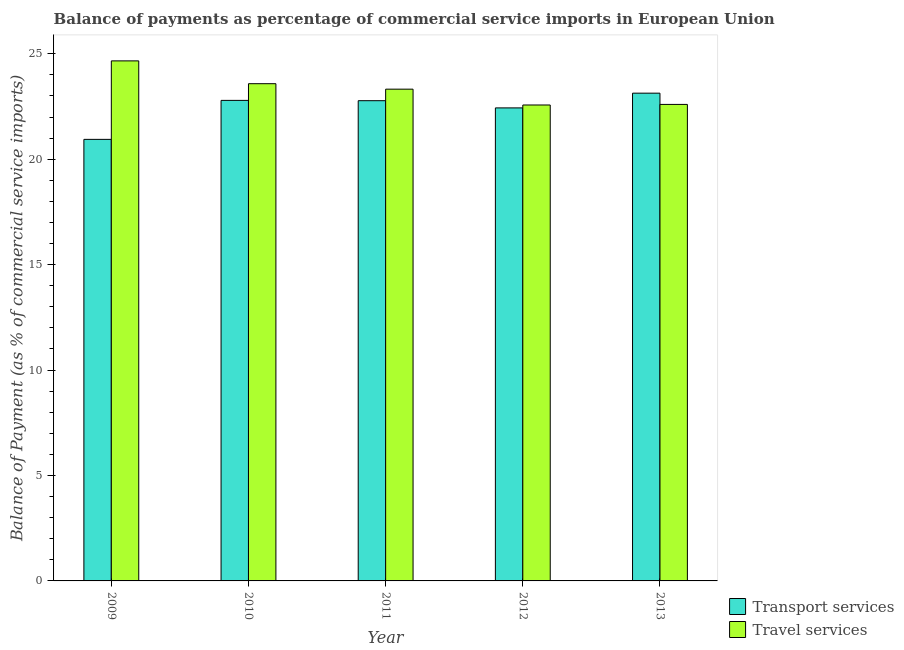How many different coloured bars are there?
Your answer should be compact. 2. How many groups of bars are there?
Give a very brief answer. 5. Are the number of bars per tick equal to the number of legend labels?
Keep it short and to the point. Yes. Are the number of bars on each tick of the X-axis equal?
Give a very brief answer. Yes. In how many cases, is the number of bars for a given year not equal to the number of legend labels?
Give a very brief answer. 0. What is the balance of payments of travel services in 2013?
Ensure brevity in your answer.  22.6. Across all years, what is the maximum balance of payments of transport services?
Your response must be concise. 23.13. Across all years, what is the minimum balance of payments of transport services?
Your response must be concise. 20.94. What is the total balance of payments of travel services in the graph?
Your answer should be very brief. 116.74. What is the difference between the balance of payments of transport services in 2009 and that in 2011?
Keep it short and to the point. -1.83. What is the difference between the balance of payments of transport services in 2011 and the balance of payments of travel services in 2009?
Offer a very short reply. 1.83. What is the average balance of payments of travel services per year?
Give a very brief answer. 23.35. In how many years, is the balance of payments of transport services greater than 15 %?
Offer a terse response. 5. What is the ratio of the balance of payments of transport services in 2009 to that in 2013?
Give a very brief answer. 0.91. What is the difference between the highest and the second highest balance of payments of transport services?
Provide a short and direct response. 0.34. What is the difference between the highest and the lowest balance of payments of travel services?
Ensure brevity in your answer.  2.09. Is the sum of the balance of payments of transport services in 2009 and 2011 greater than the maximum balance of payments of travel services across all years?
Provide a succinct answer. Yes. What does the 2nd bar from the left in 2013 represents?
Provide a succinct answer. Travel services. What does the 2nd bar from the right in 2011 represents?
Offer a very short reply. Transport services. How many bars are there?
Your answer should be very brief. 10. Are all the bars in the graph horizontal?
Provide a short and direct response. No. What is the difference between two consecutive major ticks on the Y-axis?
Your response must be concise. 5. Does the graph contain grids?
Give a very brief answer. No. What is the title of the graph?
Offer a very short reply. Balance of payments as percentage of commercial service imports in European Union. Does "Female labourers" appear as one of the legend labels in the graph?
Make the answer very short. No. What is the label or title of the X-axis?
Make the answer very short. Year. What is the label or title of the Y-axis?
Provide a short and direct response. Balance of Payment (as % of commercial service imports). What is the Balance of Payment (as % of commercial service imports) of Transport services in 2009?
Provide a short and direct response. 20.94. What is the Balance of Payment (as % of commercial service imports) in Travel services in 2009?
Keep it short and to the point. 24.66. What is the Balance of Payment (as % of commercial service imports) of Transport services in 2010?
Keep it short and to the point. 22.79. What is the Balance of Payment (as % of commercial service imports) in Travel services in 2010?
Provide a succinct answer. 23.58. What is the Balance of Payment (as % of commercial service imports) in Transport services in 2011?
Offer a terse response. 22.78. What is the Balance of Payment (as % of commercial service imports) in Travel services in 2011?
Provide a short and direct response. 23.32. What is the Balance of Payment (as % of commercial service imports) in Transport services in 2012?
Your answer should be very brief. 22.43. What is the Balance of Payment (as % of commercial service imports) of Travel services in 2012?
Give a very brief answer. 22.57. What is the Balance of Payment (as % of commercial service imports) in Transport services in 2013?
Give a very brief answer. 23.13. What is the Balance of Payment (as % of commercial service imports) in Travel services in 2013?
Your answer should be very brief. 22.6. Across all years, what is the maximum Balance of Payment (as % of commercial service imports) in Transport services?
Your answer should be compact. 23.13. Across all years, what is the maximum Balance of Payment (as % of commercial service imports) in Travel services?
Your answer should be compact. 24.66. Across all years, what is the minimum Balance of Payment (as % of commercial service imports) in Transport services?
Make the answer very short. 20.94. Across all years, what is the minimum Balance of Payment (as % of commercial service imports) in Travel services?
Give a very brief answer. 22.57. What is the total Balance of Payment (as % of commercial service imports) in Transport services in the graph?
Your response must be concise. 112.07. What is the total Balance of Payment (as % of commercial service imports) of Travel services in the graph?
Your answer should be very brief. 116.74. What is the difference between the Balance of Payment (as % of commercial service imports) of Transport services in 2009 and that in 2010?
Your answer should be compact. -1.85. What is the difference between the Balance of Payment (as % of commercial service imports) in Travel services in 2009 and that in 2010?
Provide a short and direct response. 1.08. What is the difference between the Balance of Payment (as % of commercial service imports) in Transport services in 2009 and that in 2011?
Give a very brief answer. -1.83. What is the difference between the Balance of Payment (as % of commercial service imports) in Travel services in 2009 and that in 2011?
Provide a short and direct response. 1.34. What is the difference between the Balance of Payment (as % of commercial service imports) of Transport services in 2009 and that in 2012?
Offer a terse response. -1.49. What is the difference between the Balance of Payment (as % of commercial service imports) in Travel services in 2009 and that in 2012?
Your answer should be very brief. 2.09. What is the difference between the Balance of Payment (as % of commercial service imports) in Transport services in 2009 and that in 2013?
Make the answer very short. -2.19. What is the difference between the Balance of Payment (as % of commercial service imports) in Travel services in 2009 and that in 2013?
Offer a terse response. 2.07. What is the difference between the Balance of Payment (as % of commercial service imports) in Transport services in 2010 and that in 2011?
Provide a short and direct response. 0.01. What is the difference between the Balance of Payment (as % of commercial service imports) in Travel services in 2010 and that in 2011?
Make the answer very short. 0.26. What is the difference between the Balance of Payment (as % of commercial service imports) of Transport services in 2010 and that in 2012?
Give a very brief answer. 0.36. What is the difference between the Balance of Payment (as % of commercial service imports) of Travel services in 2010 and that in 2012?
Provide a short and direct response. 1.01. What is the difference between the Balance of Payment (as % of commercial service imports) of Transport services in 2010 and that in 2013?
Provide a short and direct response. -0.34. What is the difference between the Balance of Payment (as % of commercial service imports) of Travel services in 2010 and that in 2013?
Give a very brief answer. 0.98. What is the difference between the Balance of Payment (as % of commercial service imports) of Transport services in 2011 and that in 2012?
Your response must be concise. 0.34. What is the difference between the Balance of Payment (as % of commercial service imports) of Travel services in 2011 and that in 2012?
Your answer should be compact. 0.75. What is the difference between the Balance of Payment (as % of commercial service imports) of Transport services in 2011 and that in 2013?
Your answer should be compact. -0.36. What is the difference between the Balance of Payment (as % of commercial service imports) of Travel services in 2011 and that in 2013?
Keep it short and to the point. 0.72. What is the difference between the Balance of Payment (as % of commercial service imports) of Transport services in 2012 and that in 2013?
Your response must be concise. -0.7. What is the difference between the Balance of Payment (as % of commercial service imports) in Travel services in 2012 and that in 2013?
Offer a very short reply. -0.03. What is the difference between the Balance of Payment (as % of commercial service imports) of Transport services in 2009 and the Balance of Payment (as % of commercial service imports) of Travel services in 2010?
Your response must be concise. -2.64. What is the difference between the Balance of Payment (as % of commercial service imports) in Transport services in 2009 and the Balance of Payment (as % of commercial service imports) in Travel services in 2011?
Your answer should be very brief. -2.38. What is the difference between the Balance of Payment (as % of commercial service imports) in Transport services in 2009 and the Balance of Payment (as % of commercial service imports) in Travel services in 2012?
Make the answer very short. -1.63. What is the difference between the Balance of Payment (as % of commercial service imports) in Transport services in 2009 and the Balance of Payment (as % of commercial service imports) in Travel services in 2013?
Give a very brief answer. -1.66. What is the difference between the Balance of Payment (as % of commercial service imports) in Transport services in 2010 and the Balance of Payment (as % of commercial service imports) in Travel services in 2011?
Your answer should be very brief. -0.53. What is the difference between the Balance of Payment (as % of commercial service imports) in Transport services in 2010 and the Balance of Payment (as % of commercial service imports) in Travel services in 2012?
Provide a succinct answer. 0.22. What is the difference between the Balance of Payment (as % of commercial service imports) of Transport services in 2010 and the Balance of Payment (as % of commercial service imports) of Travel services in 2013?
Offer a very short reply. 0.19. What is the difference between the Balance of Payment (as % of commercial service imports) in Transport services in 2011 and the Balance of Payment (as % of commercial service imports) in Travel services in 2012?
Your answer should be compact. 0.2. What is the difference between the Balance of Payment (as % of commercial service imports) of Transport services in 2011 and the Balance of Payment (as % of commercial service imports) of Travel services in 2013?
Provide a short and direct response. 0.18. What is the difference between the Balance of Payment (as % of commercial service imports) in Transport services in 2012 and the Balance of Payment (as % of commercial service imports) in Travel services in 2013?
Keep it short and to the point. -0.16. What is the average Balance of Payment (as % of commercial service imports) in Transport services per year?
Your answer should be very brief. 22.41. What is the average Balance of Payment (as % of commercial service imports) in Travel services per year?
Your response must be concise. 23.35. In the year 2009, what is the difference between the Balance of Payment (as % of commercial service imports) of Transport services and Balance of Payment (as % of commercial service imports) of Travel services?
Your answer should be compact. -3.72. In the year 2010, what is the difference between the Balance of Payment (as % of commercial service imports) of Transport services and Balance of Payment (as % of commercial service imports) of Travel services?
Your response must be concise. -0.79. In the year 2011, what is the difference between the Balance of Payment (as % of commercial service imports) in Transport services and Balance of Payment (as % of commercial service imports) in Travel services?
Your answer should be compact. -0.55. In the year 2012, what is the difference between the Balance of Payment (as % of commercial service imports) in Transport services and Balance of Payment (as % of commercial service imports) in Travel services?
Your answer should be compact. -0.14. In the year 2013, what is the difference between the Balance of Payment (as % of commercial service imports) in Transport services and Balance of Payment (as % of commercial service imports) in Travel services?
Give a very brief answer. 0.53. What is the ratio of the Balance of Payment (as % of commercial service imports) of Transport services in 2009 to that in 2010?
Provide a short and direct response. 0.92. What is the ratio of the Balance of Payment (as % of commercial service imports) of Travel services in 2009 to that in 2010?
Your response must be concise. 1.05. What is the ratio of the Balance of Payment (as % of commercial service imports) in Transport services in 2009 to that in 2011?
Give a very brief answer. 0.92. What is the ratio of the Balance of Payment (as % of commercial service imports) of Travel services in 2009 to that in 2011?
Offer a very short reply. 1.06. What is the ratio of the Balance of Payment (as % of commercial service imports) in Transport services in 2009 to that in 2012?
Make the answer very short. 0.93. What is the ratio of the Balance of Payment (as % of commercial service imports) of Travel services in 2009 to that in 2012?
Your response must be concise. 1.09. What is the ratio of the Balance of Payment (as % of commercial service imports) of Transport services in 2009 to that in 2013?
Offer a terse response. 0.91. What is the ratio of the Balance of Payment (as % of commercial service imports) of Travel services in 2009 to that in 2013?
Provide a succinct answer. 1.09. What is the ratio of the Balance of Payment (as % of commercial service imports) in Transport services in 2010 to that in 2011?
Make the answer very short. 1. What is the ratio of the Balance of Payment (as % of commercial service imports) of Travel services in 2010 to that in 2011?
Your answer should be very brief. 1.01. What is the ratio of the Balance of Payment (as % of commercial service imports) of Transport services in 2010 to that in 2012?
Keep it short and to the point. 1.02. What is the ratio of the Balance of Payment (as % of commercial service imports) of Travel services in 2010 to that in 2012?
Offer a very short reply. 1.04. What is the ratio of the Balance of Payment (as % of commercial service imports) of Transport services in 2010 to that in 2013?
Your answer should be compact. 0.99. What is the ratio of the Balance of Payment (as % of commercial service imports) of Travel services in 2010 to that in 2013?
Ensure brevity in your answer.  1.04. What is the ratio of the Balance of Payment (as % of commercial service imports) of Transport services in 2011 to that in 2012?
Your response must be concise. 1.02. What is the ratio of the Balance of Payment (as % of commercial service imports) in Travel services in 2011 to that in 2012?
Make the answer very short. 1.03. What is the ratio of the Balance of Payment (as % of commercial service imports) in Transport services in 2011 to that in 2013?
Your answer should be very brief. 0.98. What is the ratio of the Balance of Payment (as % of commercial service imports) in Travel services in 2011 to that in 2013?
Keep it short and to the point. 1.03. What is the ratio of the Balance of Payment (as % of commercial service imports) of Transport services in 2012 to that in 2013?
Offer a terse response. 0.97. What is the difference between the highest and the second highest Balance of Payment (as % of commercial service imports) of Transport services?
Offer a very short reply. 0.34. What is the difference between the highest and the second highest Balance of Payment (as % of commercial service imports) in Travel services?
Offer a terse response. 1.08. What is the difference between the highest and the lowest Balance of Payment (as % of commercial service imports) in Transport services?
Provide a short and direct response. 2.19. What is the difference between the highest and the lowest Balance of Payment (as % of commercial service imports) in Travel services?
Offer a terse response. 2.09. 